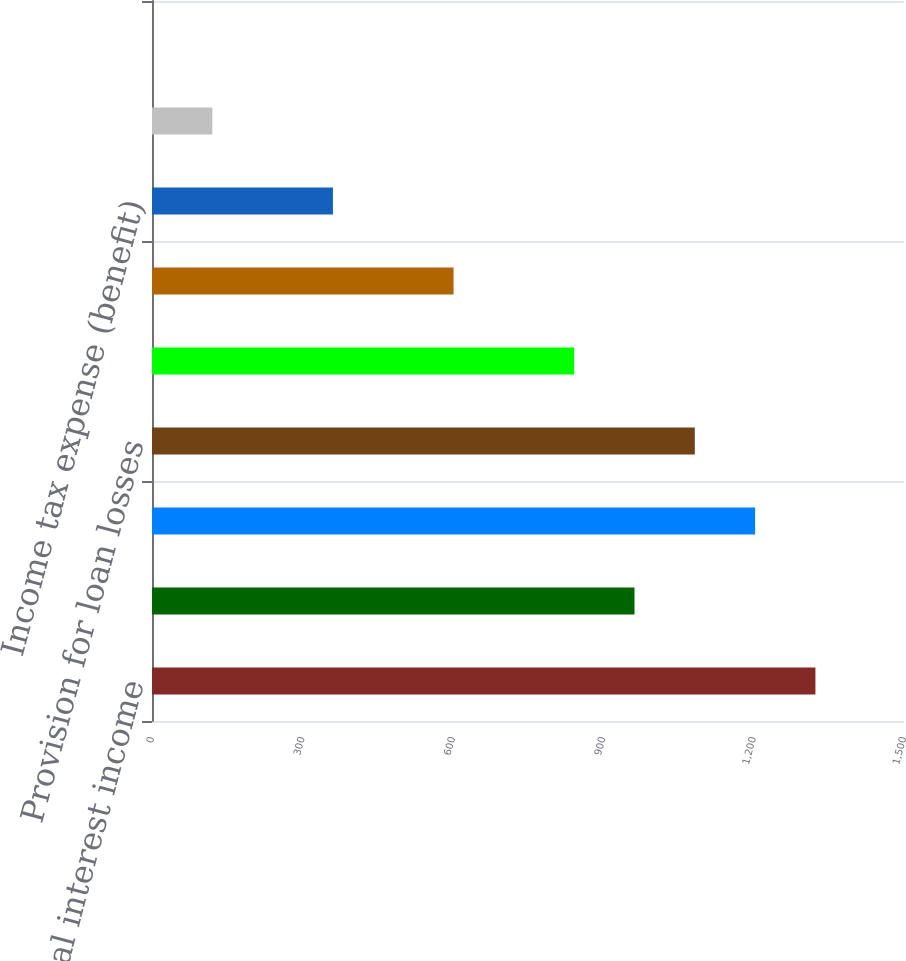<chart> <loc_0><loc_0><loc_500><loc_500><bar_chart><fcel>Total interest income<fcel>Total interest expense<fcel>Net interest income<fcel>Provision for loan losses<fcel>Net interest income after<fcel>Income (loss) from<fcel>Income tax expense (benefit)<fcel>Diluted<fcel>Cash dividends declared per<nl><fcel>1323.31<fcel>962.41<fcel>1203.01<fcel>1082.71<fcel>842.11<fcel>601.51<fcel>360.91<fcel>120.31<fcel>0.01<nl></chart> 